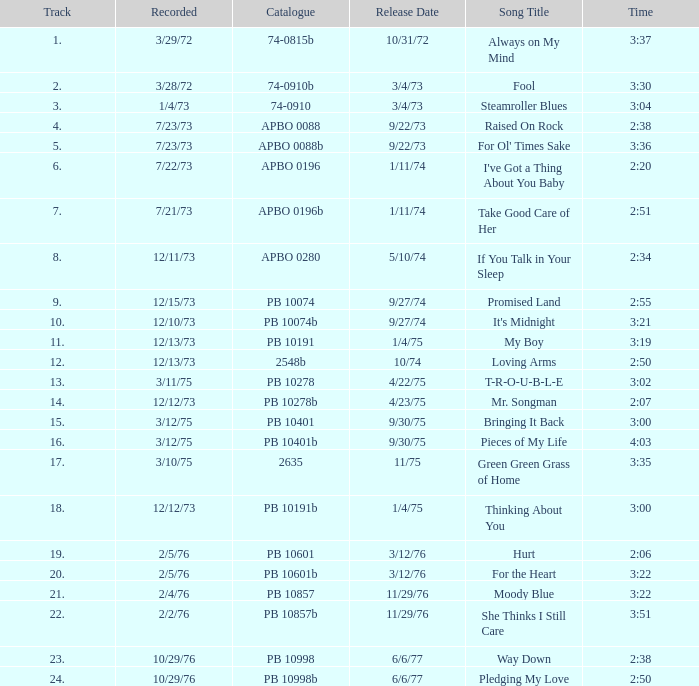Tell me the time for 6/6/77 release date and song title of way down 2:38. 